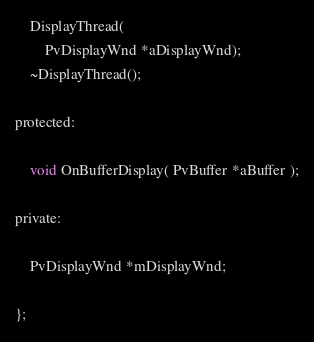<code> <loc_0><loc_0><loc_500><loc_500><_C_>	DisplayThread(
        PvDisplayWnd *aDisplayWnd);
	~DisplayThread();

protected:

    void OnBufferDisplay( PvBuffer *aBuffer );

private:

	PvDisplayWnd *mDisplayWnd;

};

</code> 